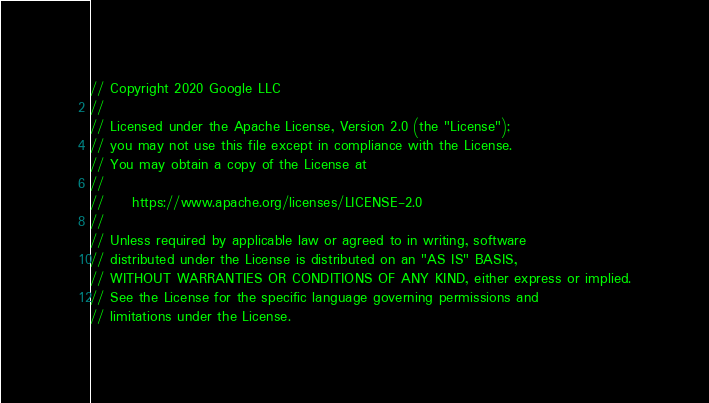<code> <loc_0><loc_0><loc_500><loc_500><_C++_>// Copyright 2020 Google LLC
//
// Licensed under the Apache License, Version 2.0 (the "License");
// you may not use this file except in compliance with the License.
// You may obtain a copy of the License at
//
//     https://www.apache.org/licenses/LICENSE-2.0
//
// Unless required by applicable law or agreed to in writing, software
// distributed under the License is distributed on an "AS IS" BASIS,
// WITHOUT WARRANTIES OR CONDITIONS OF ANY KIND, either express or implied.
// See the License for the specific language governing permissions and
// limitations under the License.
</code> 